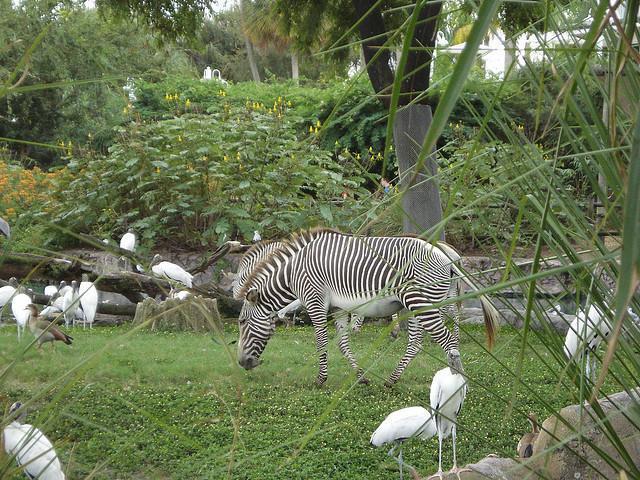How many birds are there?
Give a very brief answer. 4. 